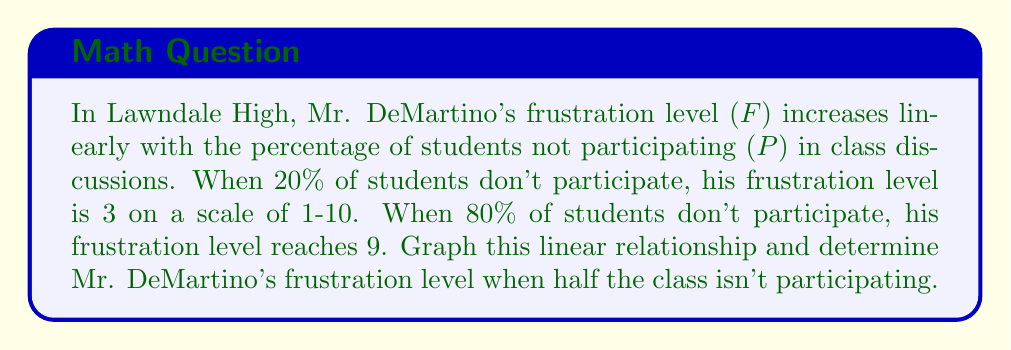Help me with this question. Let's approach this step-by-step:

1) We have two points: (20, 3) and (80, 9). Let's use these to find the slope of the line.

2) The slope formula is:
   $$m = \frac{y_2 - y_1}{x_2 - x_1} = \frac{9 - 3}{80 - 20} = \frac{6}{60} = 0.1$$

3) Now we can use the point-slope form of a line: $y - y_1 = m(x - x_1)$
   Let's use (20, 3): $F - 3 = 0.1(P - 20)$

4) Simplify to slope-intercept form:
   $F = 0.1P - 2 + 3$
   $F = 0.1P + 1$

5) This is our equation. To graph it, we can plot our two original points and draw the line through them.

6) To find Mr. DeMartino's frustration when half the class isn't participating (50%):
   $F = 0.1(50) + 1 = 5 + 1 = 6$

[asy]
import graph;
size(200);
real f(real x) {return 0.1x + 1;}
xaxis("P (%)", 0, 100, Arrow);
yaxis("F", 0, 10, Arrow);
draw(graph(f,0,100));
dot((20,3));
dot((80,9));
dot((50,6),red);
label("(20,3)",(20,3),SW);
label("(80,9)",(80,9),NE);
label("(50,6)",(50,6),SE,red);
[/asy]
Answer: $F = 0.1P + 1$; Frustration level at 50% non-participation: 6 